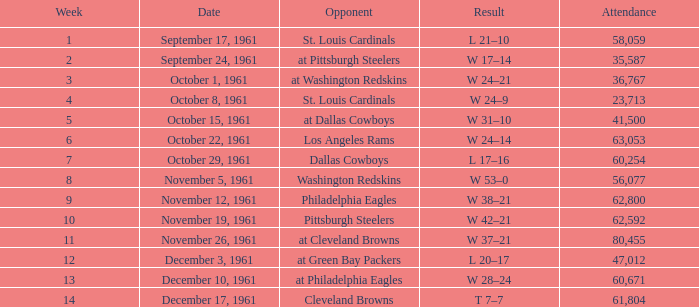In which week does washington redskins face an opponent and have an attendance greater than 56,077? 0.0. 